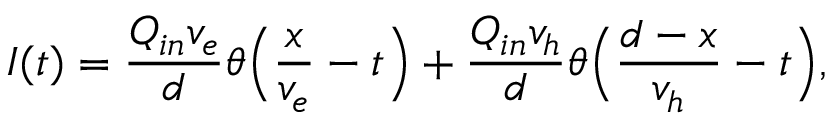<formula> <loc_0><loc_0><loc_500><loc_500>I ( t ) = \frac { Q _ { i n } v _ { e } } { d } \theta \left ( \frac { x } { v _ { e } } - t \right ) + \frac { Q _ { i n } v _ { h } } { d } \theta \left ( \frac { d - x } { v _ { h } } - t \right ) ,</formula> 